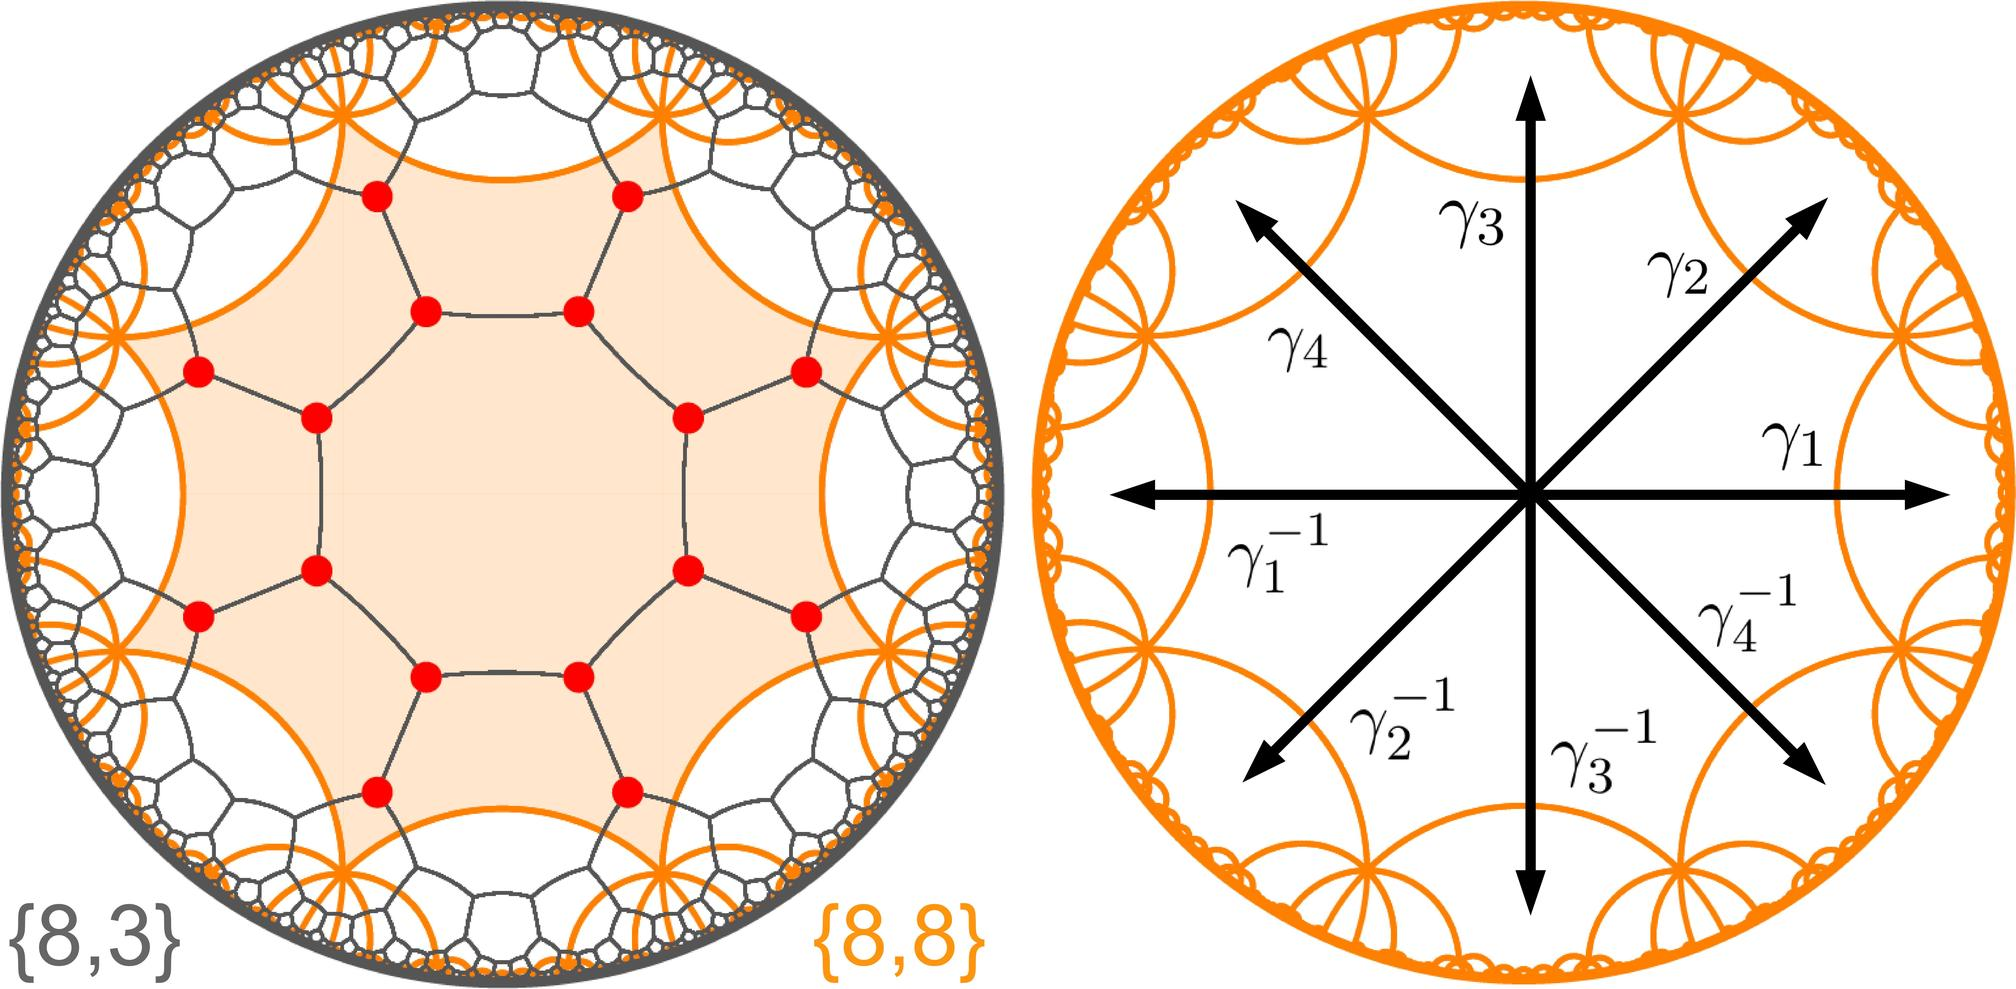What do the symbols \(\gamma_1, \gamma_2, \gamma_3, \gamma_4\) in the right figure represent? A. Directions of magnetic fields B. Different phases of a substance C. Eigenvalues of a matrix D. Roots of a polynomial equation The right figure displays a circular layout with arrows marked with \(\gamma\) symbols and negative signs, indicative of roots of a polynomial equation on a complex plane, as they are shown in pairs with their negatives, a common representation for roots of equations. Therefore, the correct answer is D. 